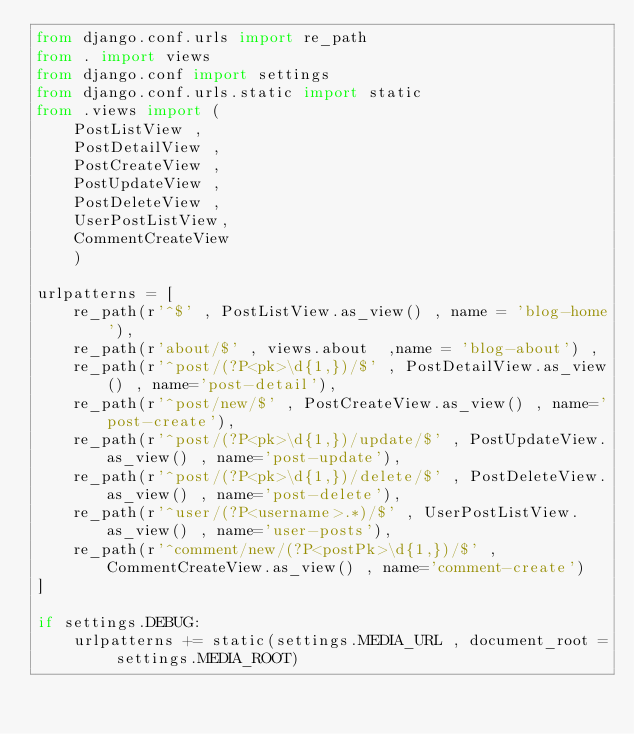Convert code to text. <code><loc_0><loc_0><loc_500><loc_500><_Python_>from django.conf.urls import re_path
from . import views
from django.conf import settings
from django.conf.urls.static import static
from .views import (
    PostListView ,
    PostDetailView ,
    PostCreateView , 
    PostUpdateView ,
    PostDeleteView ,
    UserPostListView,
    CommentCreateView
    ) 

urlpatterns = [
    re_path(r'^$' , PostListView.as_view() , name = 'blog-home'),
    re_path(r'about/$' , views.about  ,name = 'blog-about') , 
    re_path(r'^post/(?P<pk>\d{1,})/$' , PostDetailView.as_view() , name='post-detail'),
    re_path(r'^post/new/$' , PostCreateView.as_view() , name='post-create'),
    re_path(r'^post/(?P<pk>\d{1,})/update/$' , PostUpdateView.as_view() , name='post-update'),
    re_path(r'^post/(?P<pk>\d{1,})/delete/$' , PostDeleteView.as_view() , name='post-delete'),
    re_path(r'^user/(?P<username>.*)/$' , UserPostListView.as_view() , name='user-posts'),
    re_path(r'^comment/new/(?P<postPk>\d{1,})/$' , CommentCreateView.as_view() , name='comment-create')
]

if settings.DEBUG:
    urlpatterns += static(settings.MEDIA_URL , document_root = settings.MEDIA_ROOT)</code> 